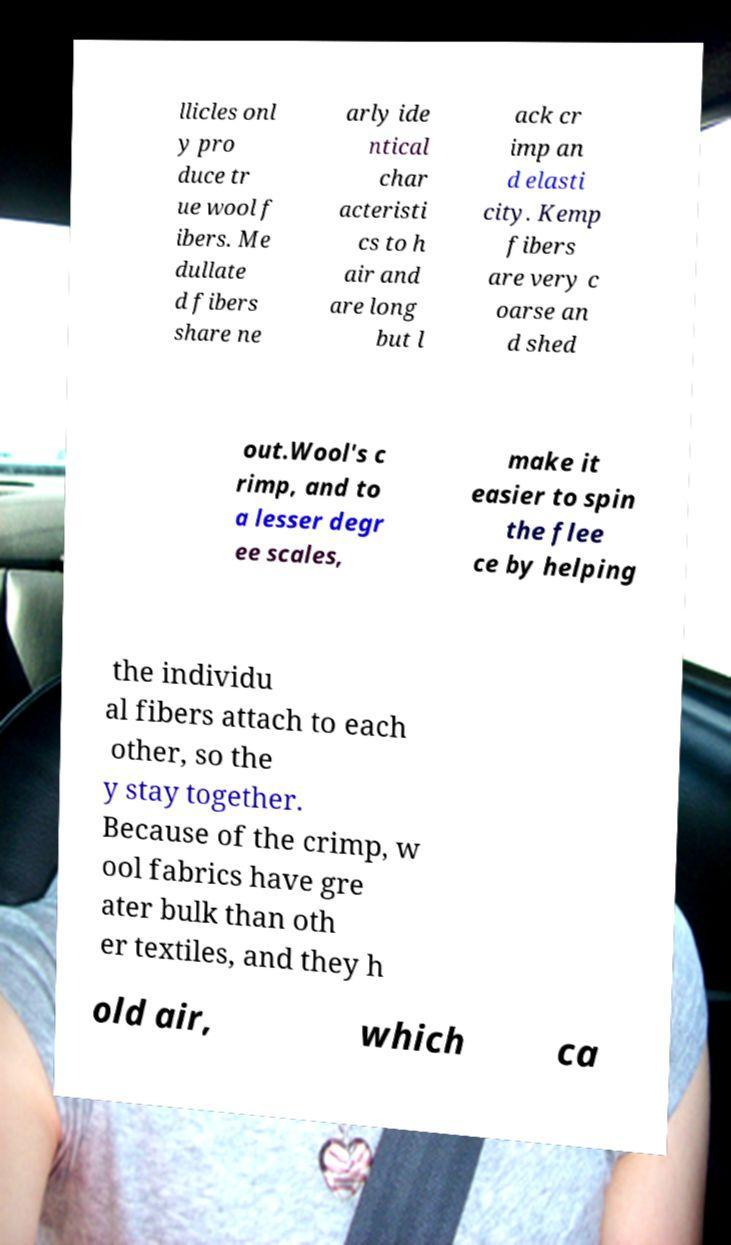What messages or text are displayed in this image? I need them in a readable, typed format. llicles onl y pro duce tr ue wool f ibers. Me dullate d fibers share ne arly ide ntical char acteristi cs to h air and are long but l ack cr imp an d elasti city. Kemp fibers are very c oarse an d shed out.Wool's c rimp, and to a lesser degr ee scales, make it easier to spin the flee ce by helping the individu al fibers attach to each other, so the y stay together. Because of the crimp, w ool fabrics have gre ater bulk than oth er textiles, and they h old air, which ca 